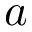Convert formula to latex. <formula><loc_0><loc_0><loc_500><loc_500>a</formula> 